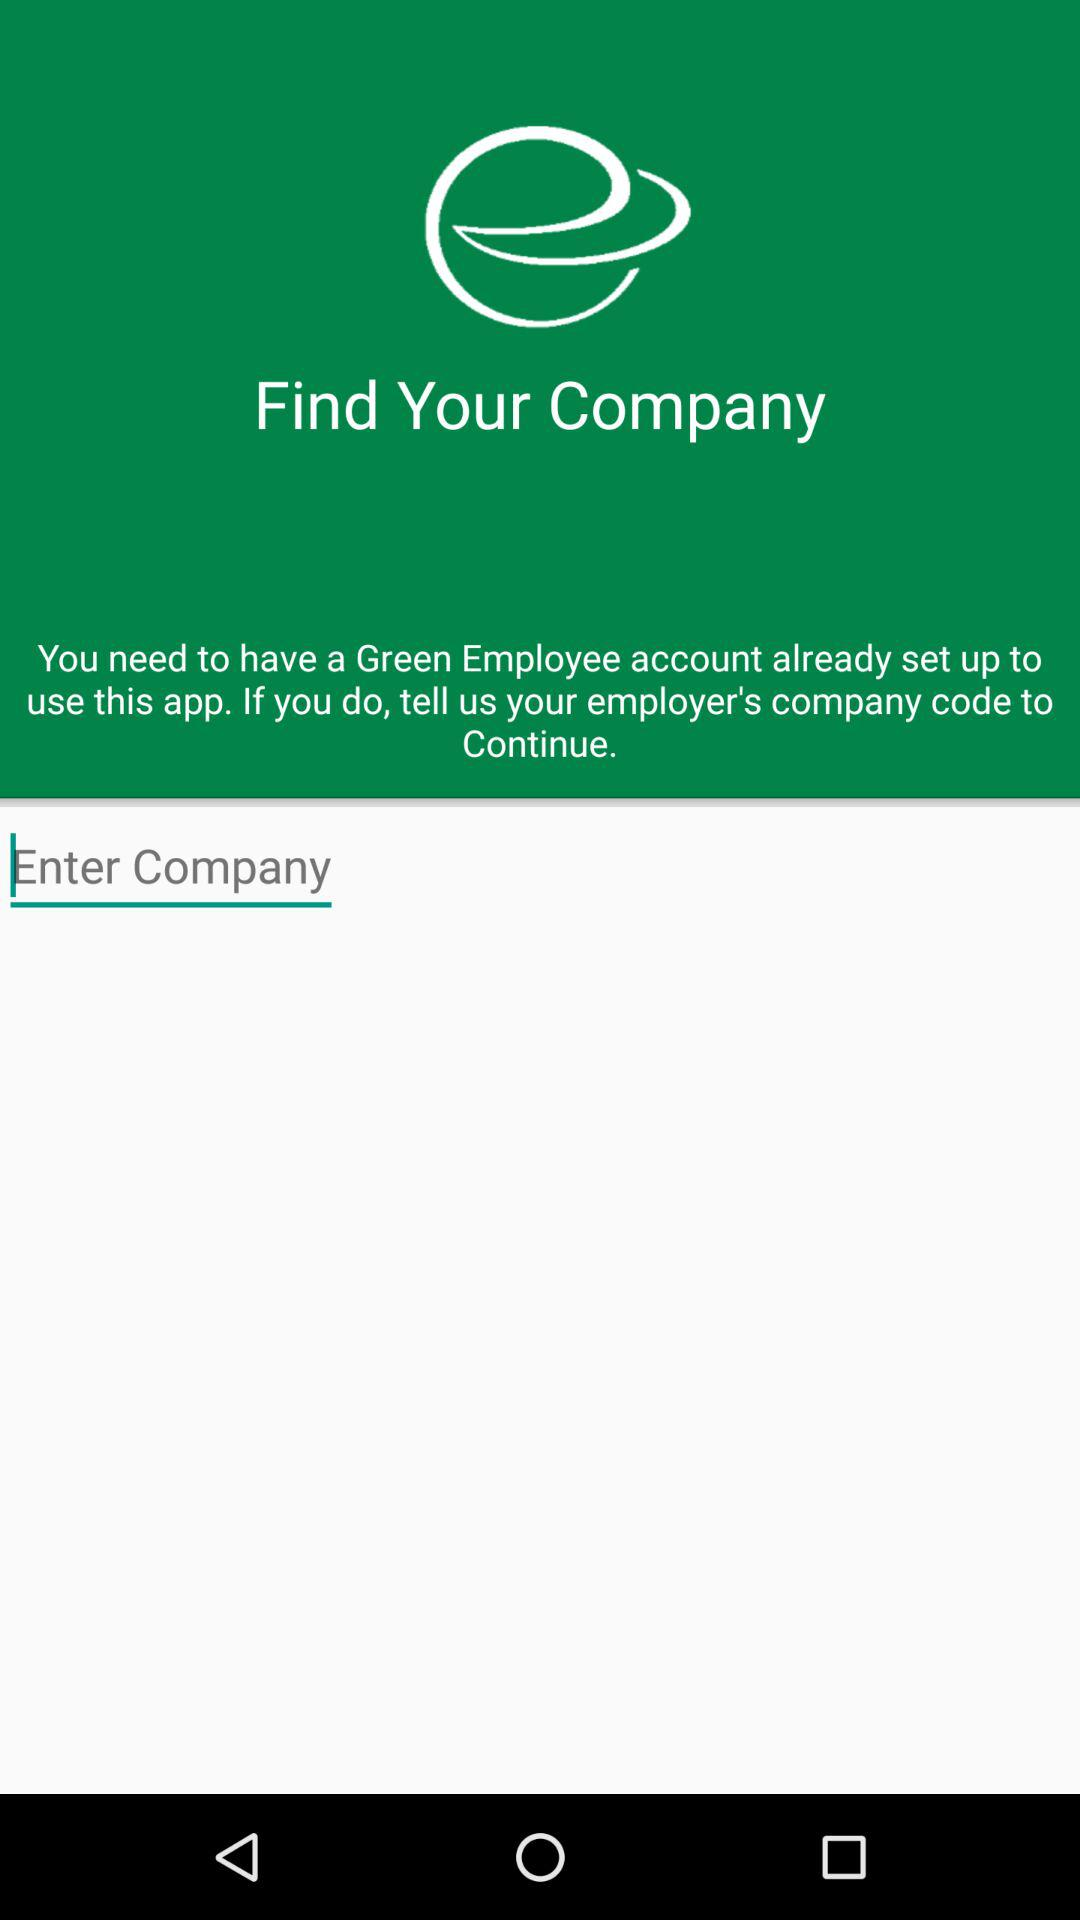What is the application name? The application name is "Green Employee". 